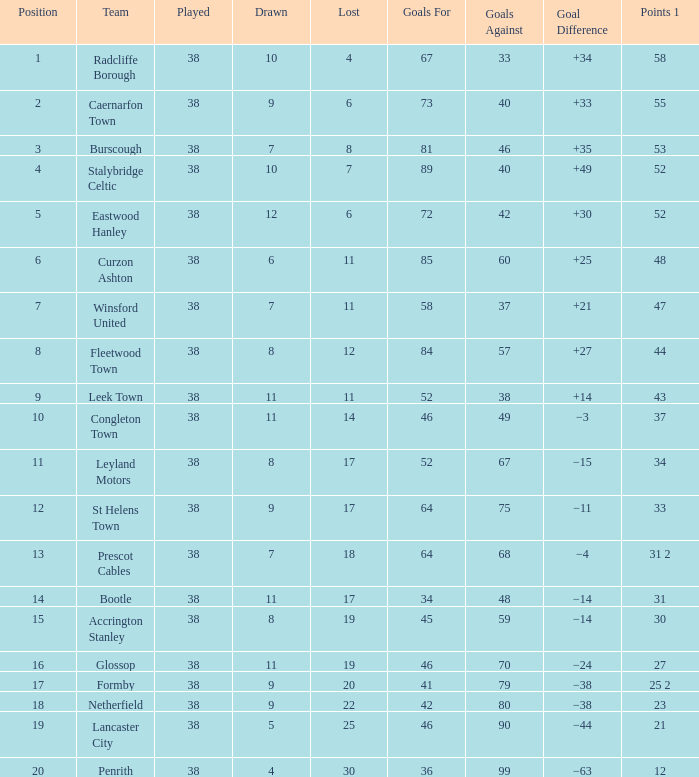WHAT POINTS 1 HAD A 22 LOST? 23.0. 